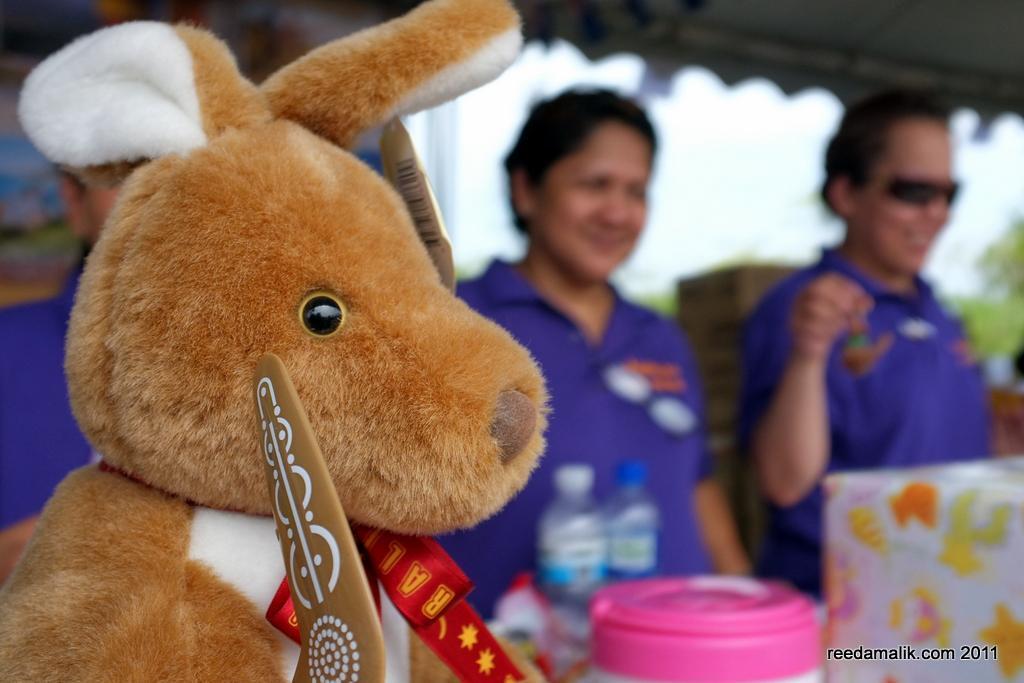How would you summarize this image in a sentence or two? This picture is clicked outside. On the left we can see a soft toy. On the right we can see the group of persons wearing blue color t-shirts and standing and there are some items seems to be placed on the top of the table. In the background there is a sky. At the bottom right corner there is a text on the image. 